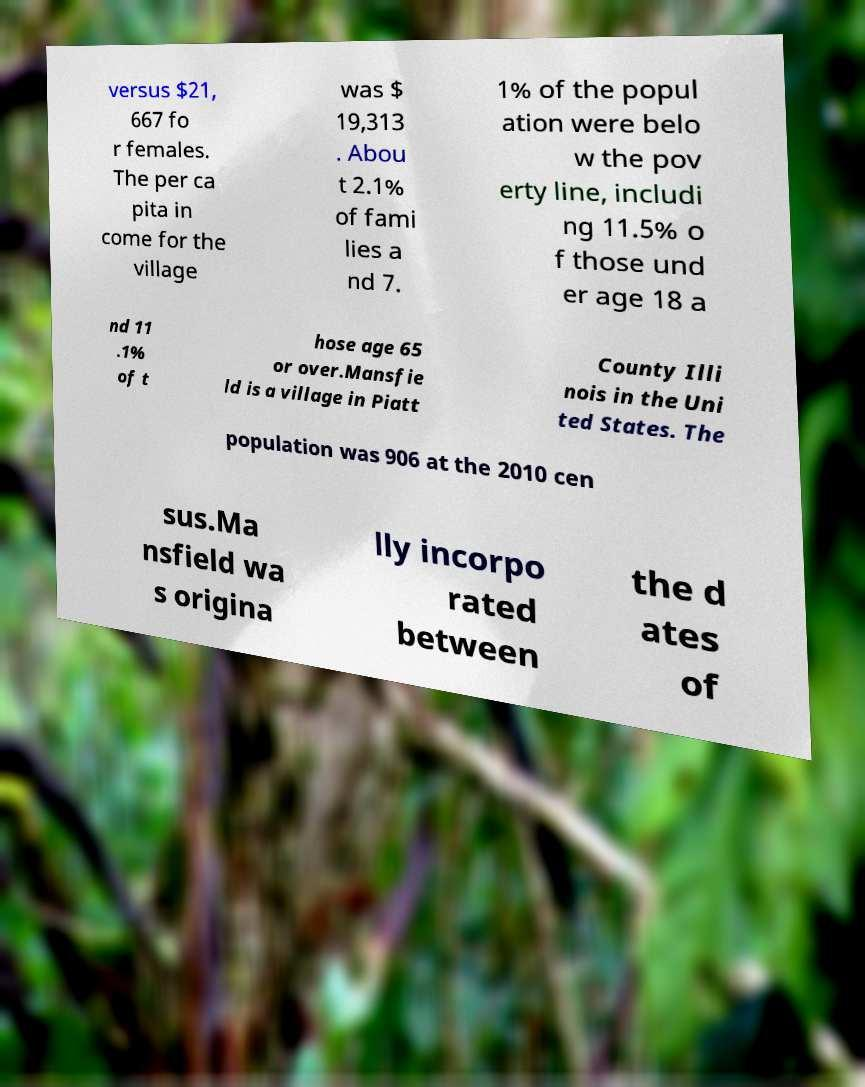For documentation purposes, I need the text within this image transcribed. Could you provide that? versus $21, 667 fo r females. The per ca pita in come for the village was $ 19,313 . Abou t 2.1% of fami lies a nd 7. 1% of the popul ation were belo w the pov erty line, includi ng 11.5% o f those und er age 18 a nd 11 .1% of t hose age 65 or over.Mansfie ld is a village in Piatt County Illi nois in the Uni ted States. The population was 906 at the 2010 cen sus.Ma nsfield wa s origina lly incorpo rated between the d ates of 